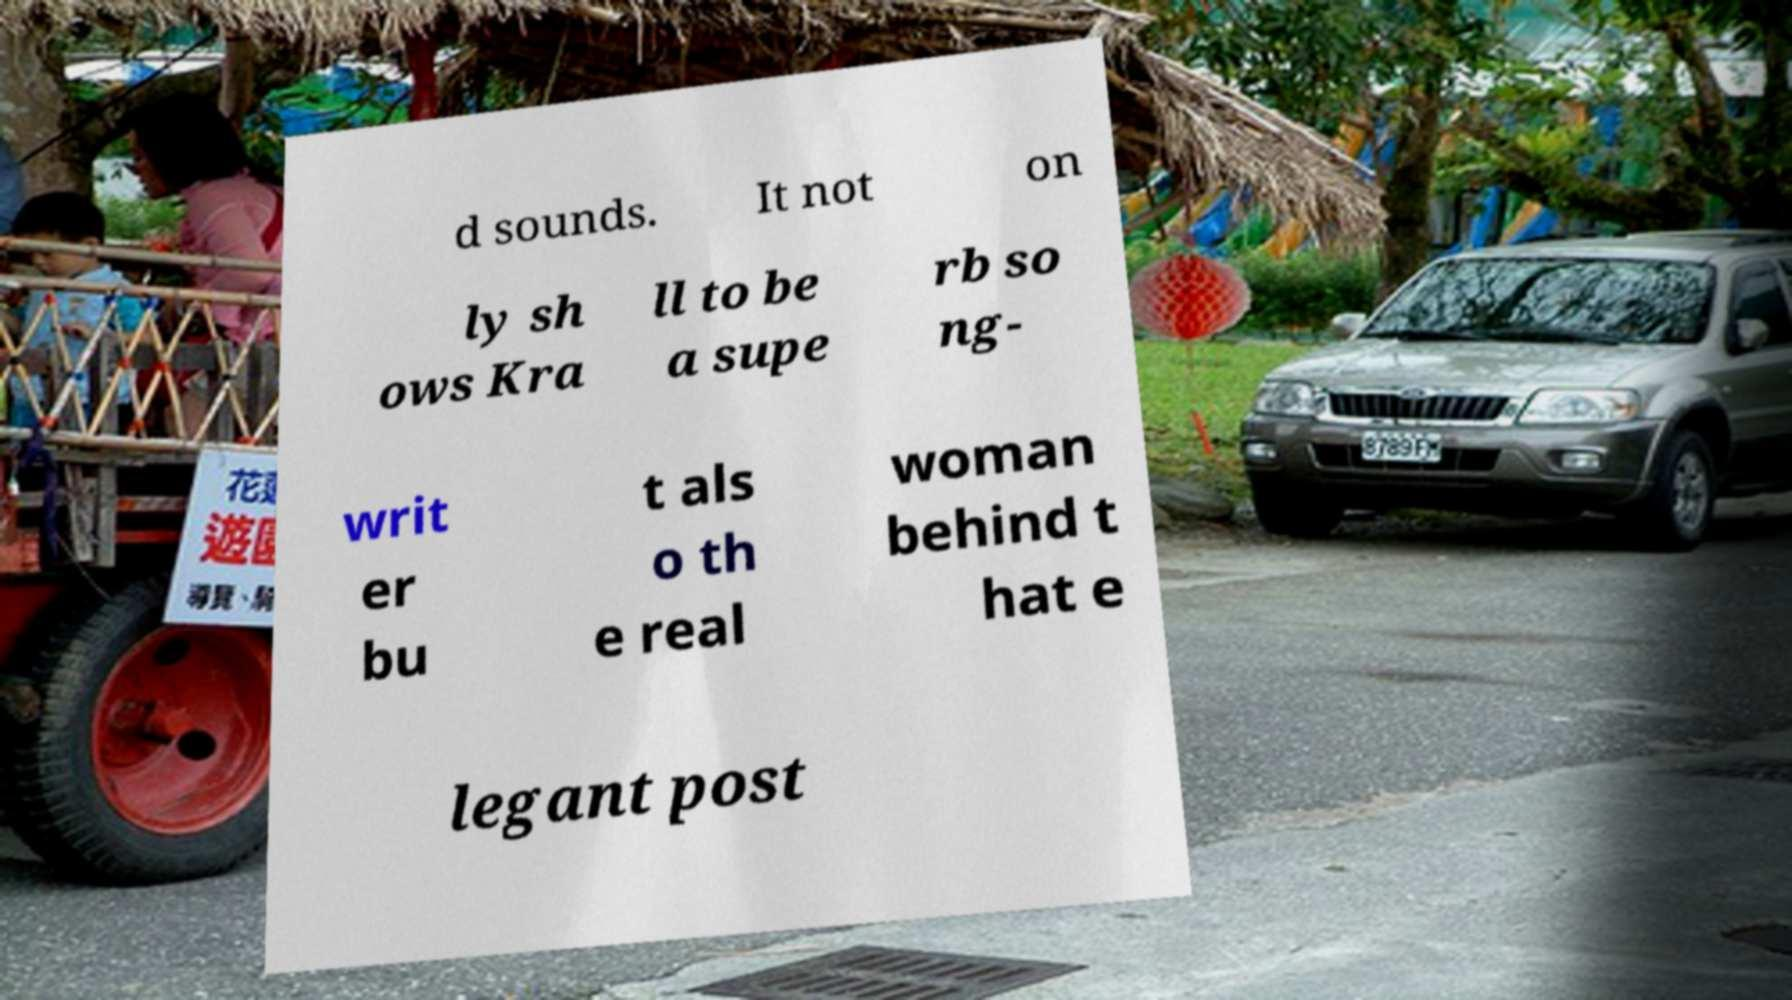Can you read and provide the text displayed in the image?This photo seems to have some interesting text. Can you extract and type it out for me? d sounds. It not on ly sh ows Kra ll to be a supe rb so ng- writ er bu t als o th e real woman behind t hat e legant post 